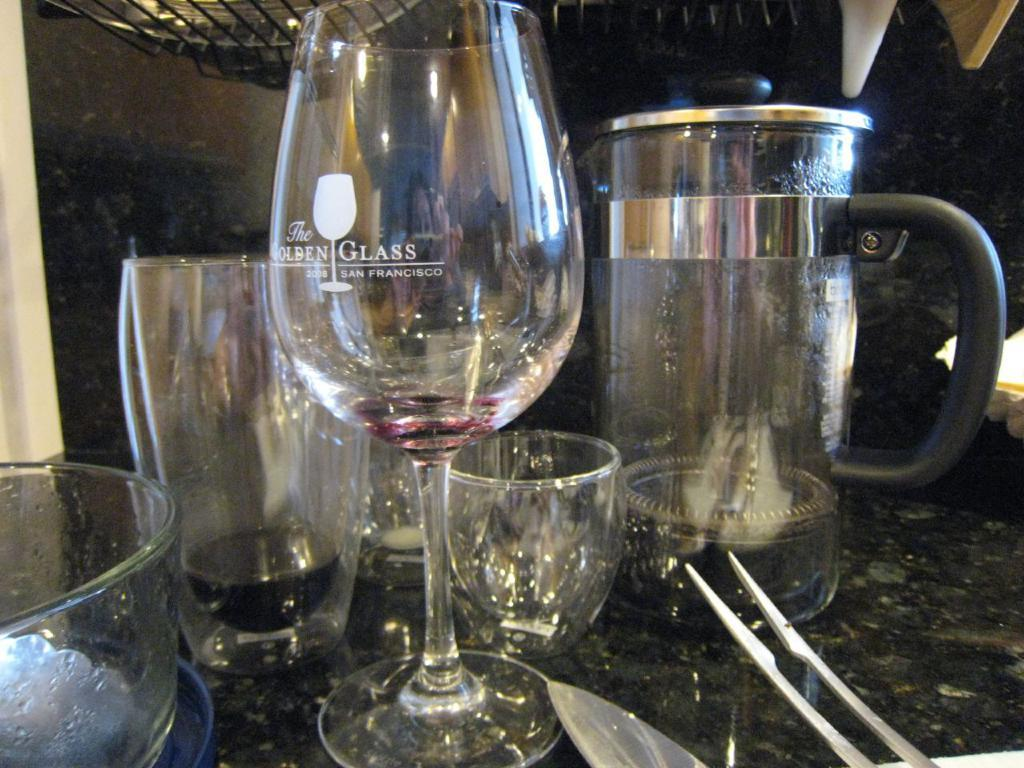What is located in the foreground of the image? There is a jar in the foreground of the image. What else can be seen on the stone surface in the foreground? There are glasses on the stone surface in the foreground. What is present at the top of the image? There is a mesh at the top of the image, and there are objects visible there as well. Can you describe the unidentified object at the bottom of the image? Unfortunately, the facts provided do not give enough information to describe the unidentified object at the bottom of the image. What type of territory is being claimed by the squirrel in the image? There is no squirrel present in the image, so no territory is being claimed. What record is being broken by the objects at the top of the image? There is no record being broken in the image; it simply shows objects and a mesh at the top. 